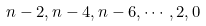Convert formula to latex. <formula><loc_0><loc_0><loc_500><loc_500>n - 2 , n - 4 , n - 6 , \cdots , 2 , 0</formula> 